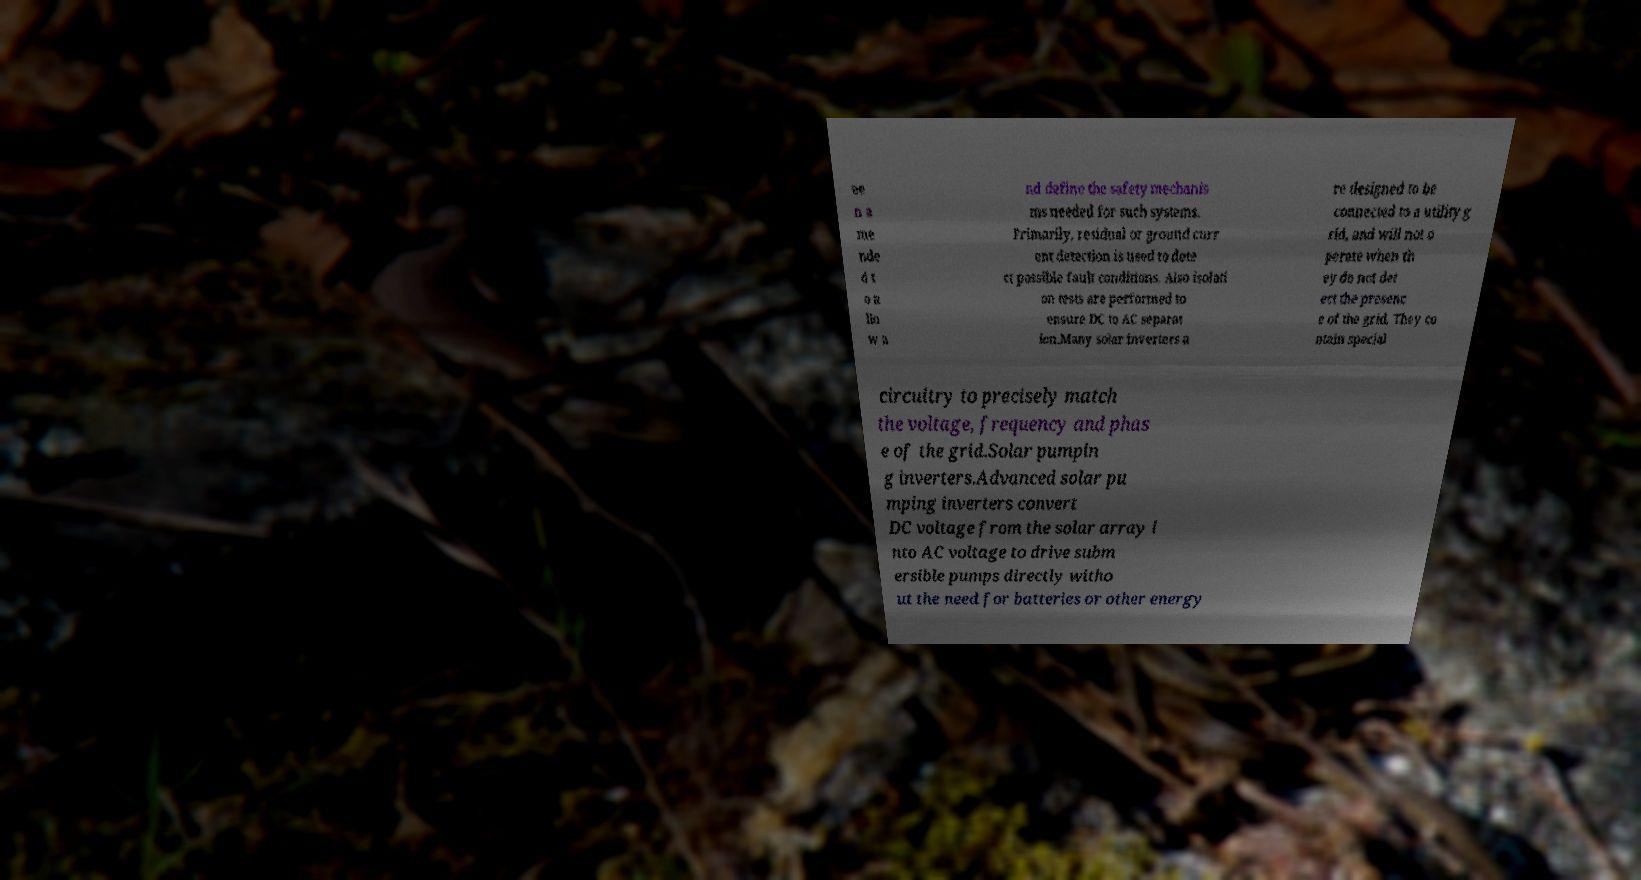Can you read and provide the text displayed in the image?This photo seems to have some interesting text. Can you extract and type it out for me? ee n a me nde d t o a llo w a nd define the safety mechanis ms needed for such systems. Primarily, residual or ground curr ent detection is used to dete ct possible fault conditions. Also isolati on tests are performed to ensure DC to AC separat ion.Many solar inverters a re designed to be connected to a utility g rid, and will not o perate when th ey do not det ect the presenc e of the grid. They co ntain special circuitry to precisely match the voltage, frequency and phas e of the grid.Solar pumpin g inverters.Advanced solar pu mping inverters convert DC voltage from the solar array i nto AC voltage to drive subm ersible pumps directly witho ut the need for batteries or other energy 